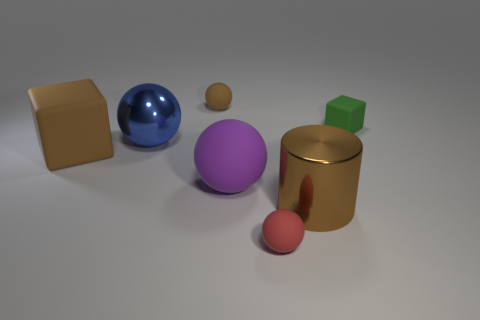There is a tiny brown ball; are there any big metal spheres to the right of it?
Provide a succinct answer. No. What number of objects are either shiny objects behind the brown matte cube or tiny red rubber objects?
Provide a succinct answer. 2. What number of big things are right of the matte block to the left of the tiny block?
Your answer should be very brief. 3. Is the number of metal spheres that are on the right side of the purple thing less than the number of objects behind the blue ball?
Make the answer very short. Yes. There is a brown thing on the left side of the small matte ball left of the red rubber ball; what shape is it?
Offer a very short reply. Cube. How many other things are there of the same material as the big purple ball?
Your response must be concise. 4. Are there more big brown blocks than big cyan balls?
Offer a very short reply. Yes. What size is the matte cube that is on the right side of the small rubber sphere that is behind the rubber block that is on the left side of the big brown metal cylinder?
Your answer should be compact. Small. Is the size of the red matte object the same as the purple rubber object that is on the right side of the brown matte cube?
Offer a very short reply. No. Is the number of metallic spheres on the right side of the metal cylinder less than the number of tiny red rubber cylinders?
Make the answer very short. No. 